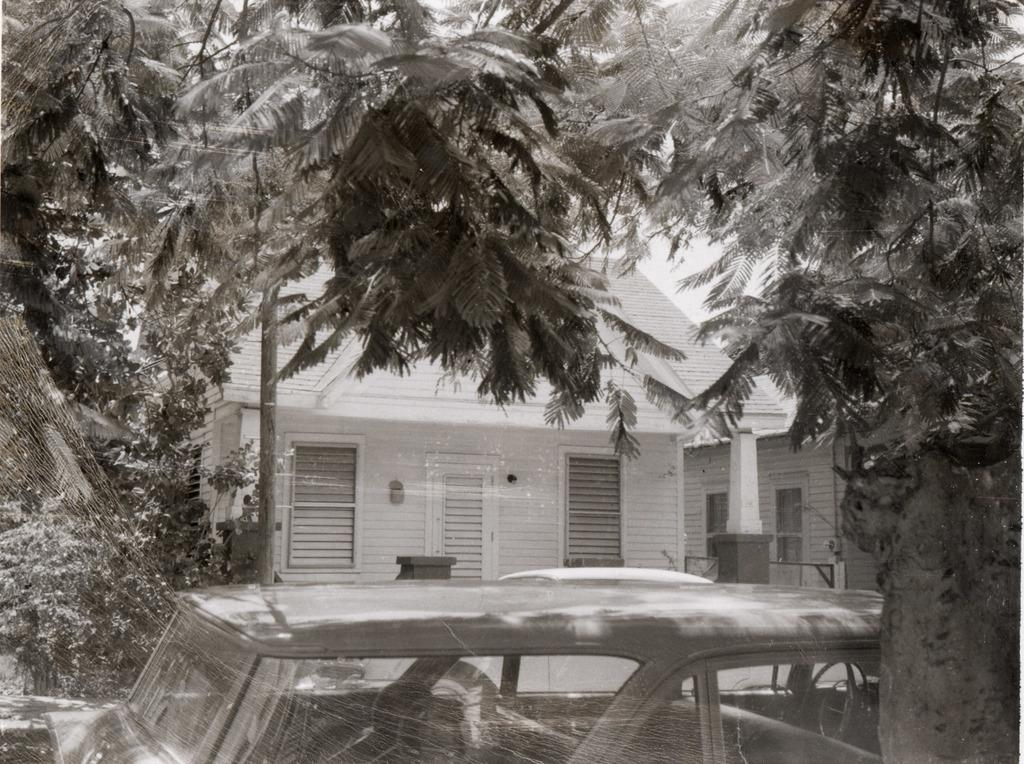What is the color scheme of the image? The image is black and white. What can be seen on the bottom of the image? There is a vehicle, a spider web, and a tree on the bottom of the image. What is visible in the background of the image? There is a white car, two houses, and trees in the background of the image. How many kittens are sitting on the silver actor's lap in the image? There are no kittens or actors present in the image. 